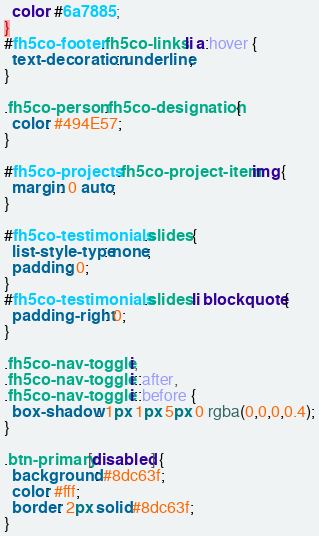Convert code to text. <code><loc_0><loc_0><loc_500><loc_500><_CSS_>  color: #6a7885;
}
#fh5co-footer .fh5co-links li a:hover {
  text-decoration: underline;
}

.fh5co-person .fh5co-designation {
  color: #494E57;
}

#fh5co-projects .fh5co-project-item img {
  margin: 0 auto;
}

#fh5co-testimonials .slides {
  list-style-type: none;
  padding: 0;
}
#fh5co-testimonials .slides li blockquote {
  padding-right: 0;
}

.fh5co-nav-toggle i,
.fh5co-nav-toggle i::after,
.fh5co-nav-toggle i::before {
  box-shadow: 1px 1px 5px 0 rgba(0,0,0,0.4);
}

.btn-primary[disabled] {
  background: #8dc63f;
  color: #fff;
  border: 2px solid #8dc63f;
}
</code> 